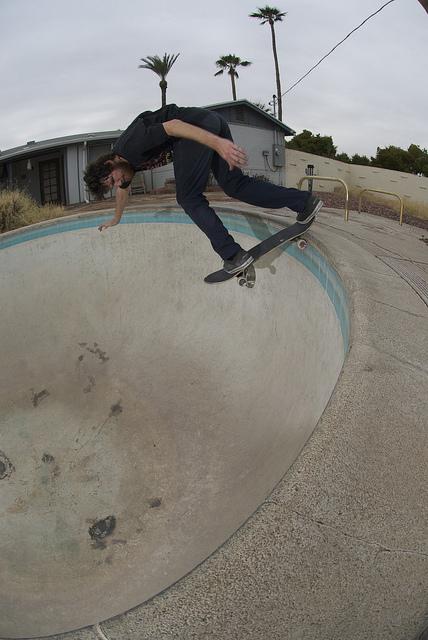Is the skater wearing a helmet?
Answer briefly. No. What type of trees are in the background?
Be succinct. Palm. What color are the wheels on the skateboard?
Write a very short answer. White. Is this a pool?
Quick response, please. Yes. Is the man wearing a helmet?
Short answer required. No. Is this activity being performed in a designated area?
Short answer required. Yes. What type of skateboard ramp is the skateboarder on?
Answer briefly. Round. Is the grass green?
Answer briefly. No. Is he in a skating ring?
Concise answer only. No. 